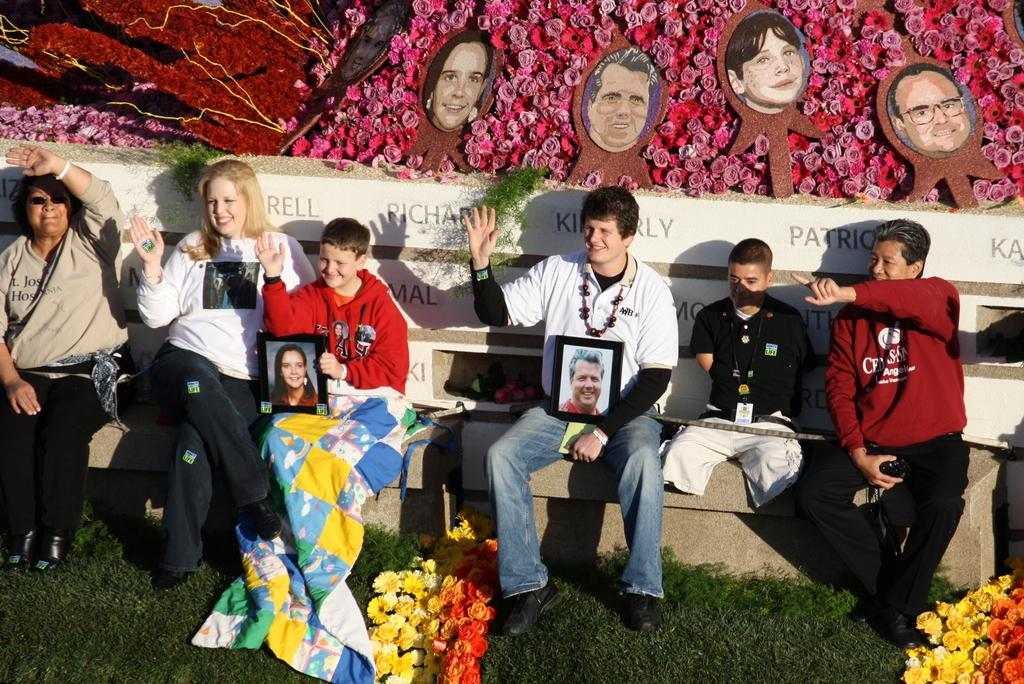How many people are in the image? There is a group of people in the image. What are the people doing in the image? The people are sitting on benches. What are two people holding in the image? Two people are holding frames with their hands. What type of vegetation is present in the image? There are flowers and grass in the image. What can be seen in the background of the image? There are photos in the background of the image. What type of trail can be seen in the image? There is no trail present in the image. What alarm is going off in the image? There is no alarm present in the image. 